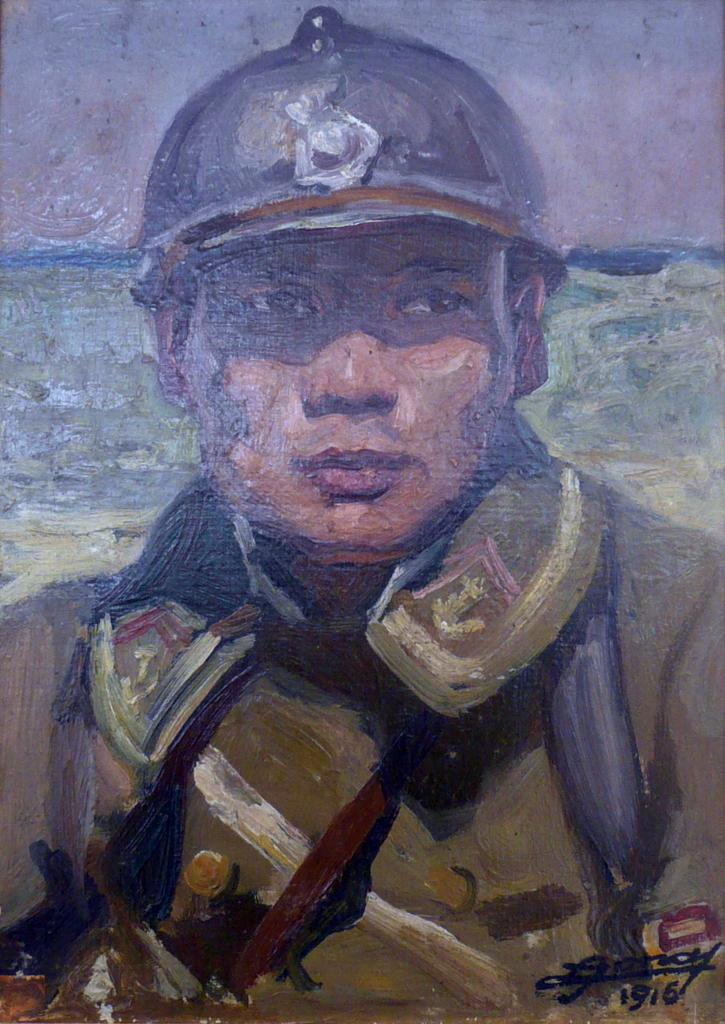What is depicted in the image? There is a painting of a man in the image. Can you describe any additional details about the painting? There is text in the bottom right corner of the image. Is there a servant standing next to the man in the painting? There is no servant present in the painting; it only depicts a man. Can you tell me how much insurance coverage the man in the painting has? There is no information about insurance coverage in the image, as it only contains a painting of a man and text in the bottom right corner. 